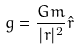Convert formula to latex. <formula><loc_0><loc_0><loc_500><loc_500>g = \frac { G m } { | r | ^ { 2 } } \hat { r }</formula> 